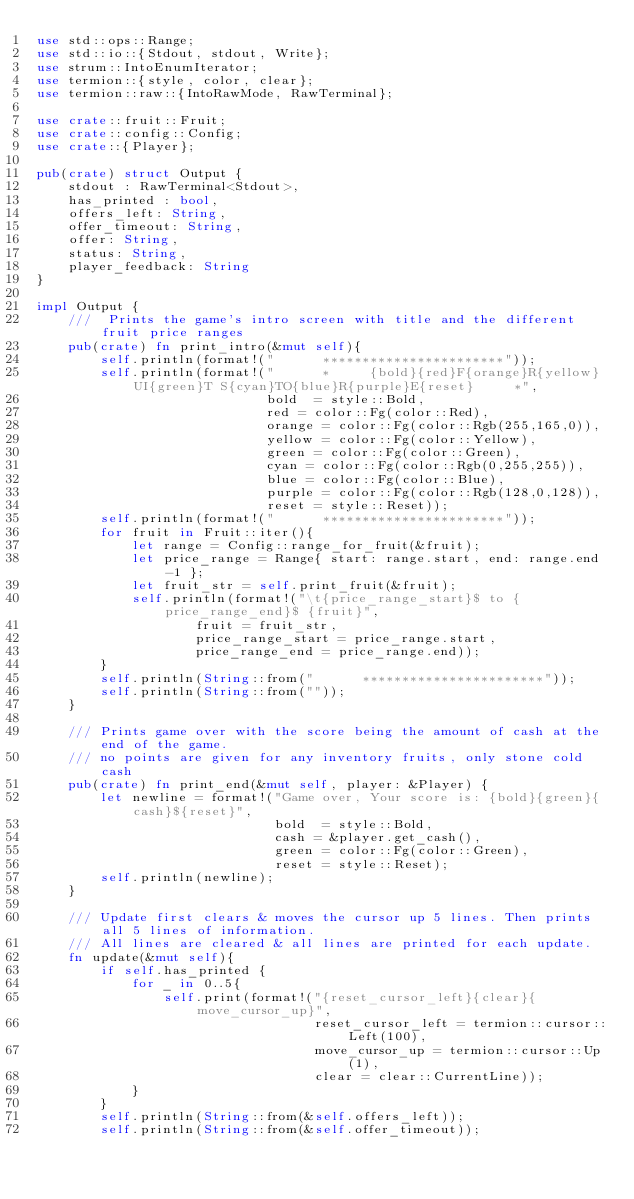<code> <loc_0><loc_0><loc_500><loc_500><_Rust_>use std::ops::Range;
use std::io::{Stdout, stdout, Write};
use strum::IntoEnumIterator;
use termion::{style, color, clear};
use termion::raw::{IntoRawMode, RawTerminal};

use crate::fruit::Fruit;
use crate::config::Config;
use crate::{Player};

pub(crate) struct Output {
    stdout : RawTerminal<Stdout>,
    has_printed : bool,
    offers_left: String,
    offer_timeout: String,
    offer: String,
    status: String,
    player_feedback: String
}

impl Output {
    ///  Prints the game's intro screen with title and the different fruit price ranges
    pub(crate) fn print_intro(&mut self){
        self.println(format!("      ***********************"));
        self.println(format!("      *     {bold}{red}F{orange}R{yellow}UI{green}T S{cyan}TO{blue}R{purple}E{reset}     *",
                             bold  = style::Bold,
                             red = color::Fg(color::Red),
                             orange = color::Fg(color::Rgb(255,165,0)),
                             yellow = color::Fg(color::Yellow),
                             green = color::Fg(color::Green),
                             cyan = color::Fg(color::Rgb(0,255,255)),
                             blue = color::Fg(color::Blue),
                             purple = color::Fg(color::Rgb(128,0,128)),
                             reset = style::Reset));
        self.println(format!("      ***********************"));
        for fruit in Fruit::iter(){
            let range = Config::range_for_fruit(&fruit);
            let price_range = Range{ start: range.start, end: range.end-1 };
            let fruit_str = self.print_fruit(&fruit);
            self.println(format!("\t{price_range_start}$ to {price_range_end}$ {fruit}",
                    fruit = fruit_str,
                    price_range_start = price_range.start,
                    price_range_end = price_range.end));
        }
        self.println(String::from("      ***********************"));
        self.println(String::from(""));
    }

    /// Prints game over with the score being the amount of cash at the end of the game.
    /// no points are given for any inventory fruits, only stone cold cash
    pub(crate) fn print_end(&mut self, player: &Player) {
        let newline = format!("Game over, Your score is: {bold}{green}{cash}${reset}",
                              bold  = style::Bold,
                              cash = &player.get_cash(),
                              green = color::Fg(color::Green),
                              reset = style::Reset);
        self.println(newline);
    }

    /// Update first clears & moves the cursor up 5 lines. Then prints all 5 lines of information.
    /// All lines are cleared & all lines are printed for each update.
    fn update(&mut self){
        if self.has_printed {
            for _ in 0..5{
                self.print(format!("{reset_cursor_left}{clear}{move_cursor_up}",
                                   reset_cursor_left = termion::cursor::Left(100),
                                   move_cursor_up = termion::cursor::Up(1),
                                   clear = clear::CurrentLine));
            }
        }
        self.println(String::from(&self.offers_left));
        self.println(String::from(&self.offer_timeout));</code> 